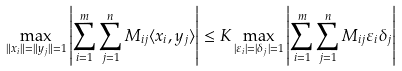<formula> <loc_0><loc_0><loc_500><loc_500>\max _ { \| x _ { i } \| = \| y _ { j } \| = 1 } \left | \sum _ { i = 1 } ^ { m } \sum _ { j = 1 } ^ { n } M _ { i j } \langle x _ { i } , y _ { j } \rangle \right | \leq K \max _ { | \varepsilon _ { i } | = | \delta _ { j } | = 1 } \left | \sum _ { i = 1 } ^ { m } \sum _ { j = 1 } ^ { n } M _ { i j } \varepsilon _ { i } \delta _ { j } \right |</formula> 